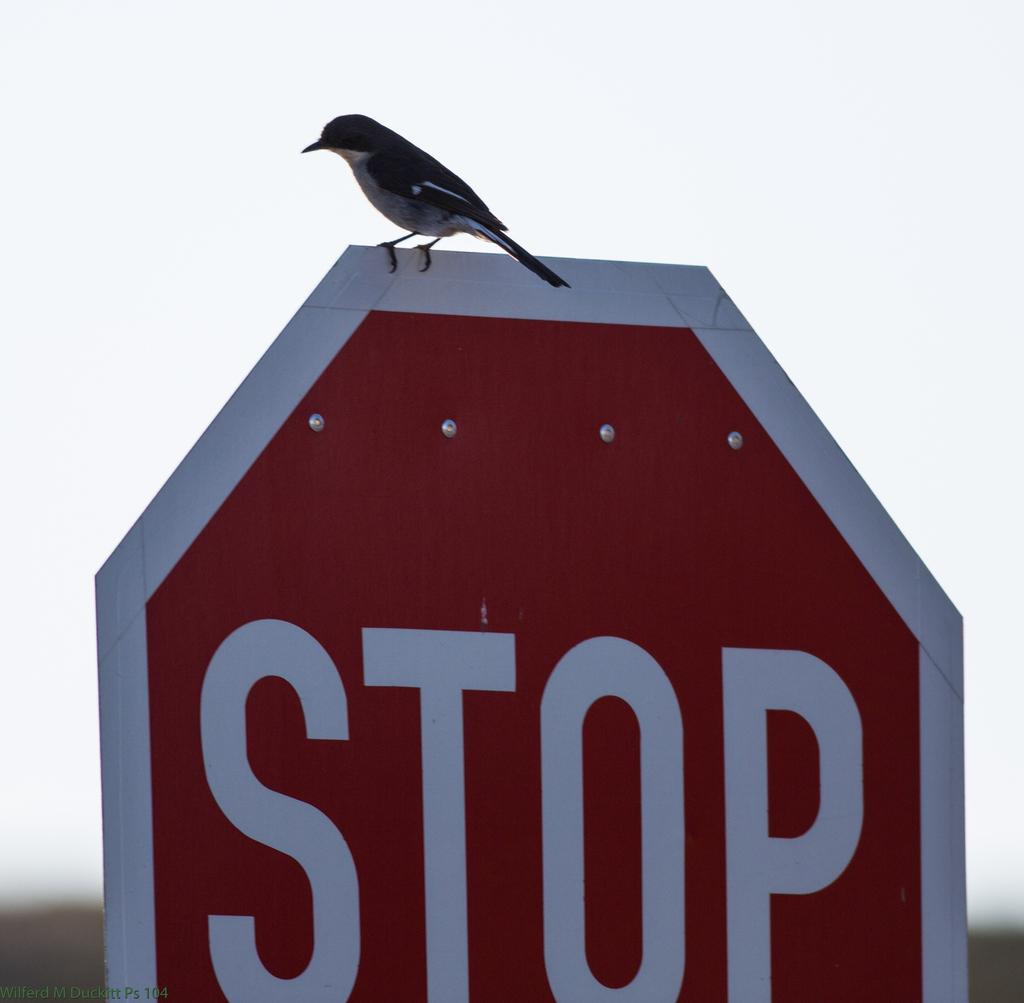What is on the signboard in the image? There is a bird on a signboard in the image. What color is the background of the image? The background of the image is white. Where is the watermark located in the image? The watermark is on the left side bottom of the image. How does the bird adjust its knot in the image? There is no knot present in the image, as the bird is on a signboard and not tied up. 